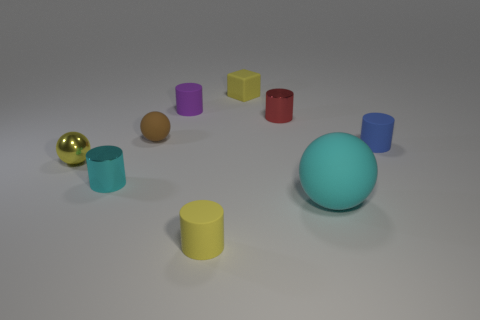Subtract all blue cylinders. How many cylinders are left? 4 Subtract all tiny blue cylinders. How many cylinders are left? 4 Subtract all gray cylinders. Subtract all gray balls. How many cylinders are left? 5 Subtract all spheres. How many objects are left? 6 Add 9 small yellow matte cubes. How many small yellow matte cubes exist? 10 Subtract 0 blue blocks. How many objects are left? 9 Subtract all big metal things. Subtract all tiny cylinders. How many objects are left? 4 Add 4 large rubber spheres. How many large rubber spheres are left? 5 